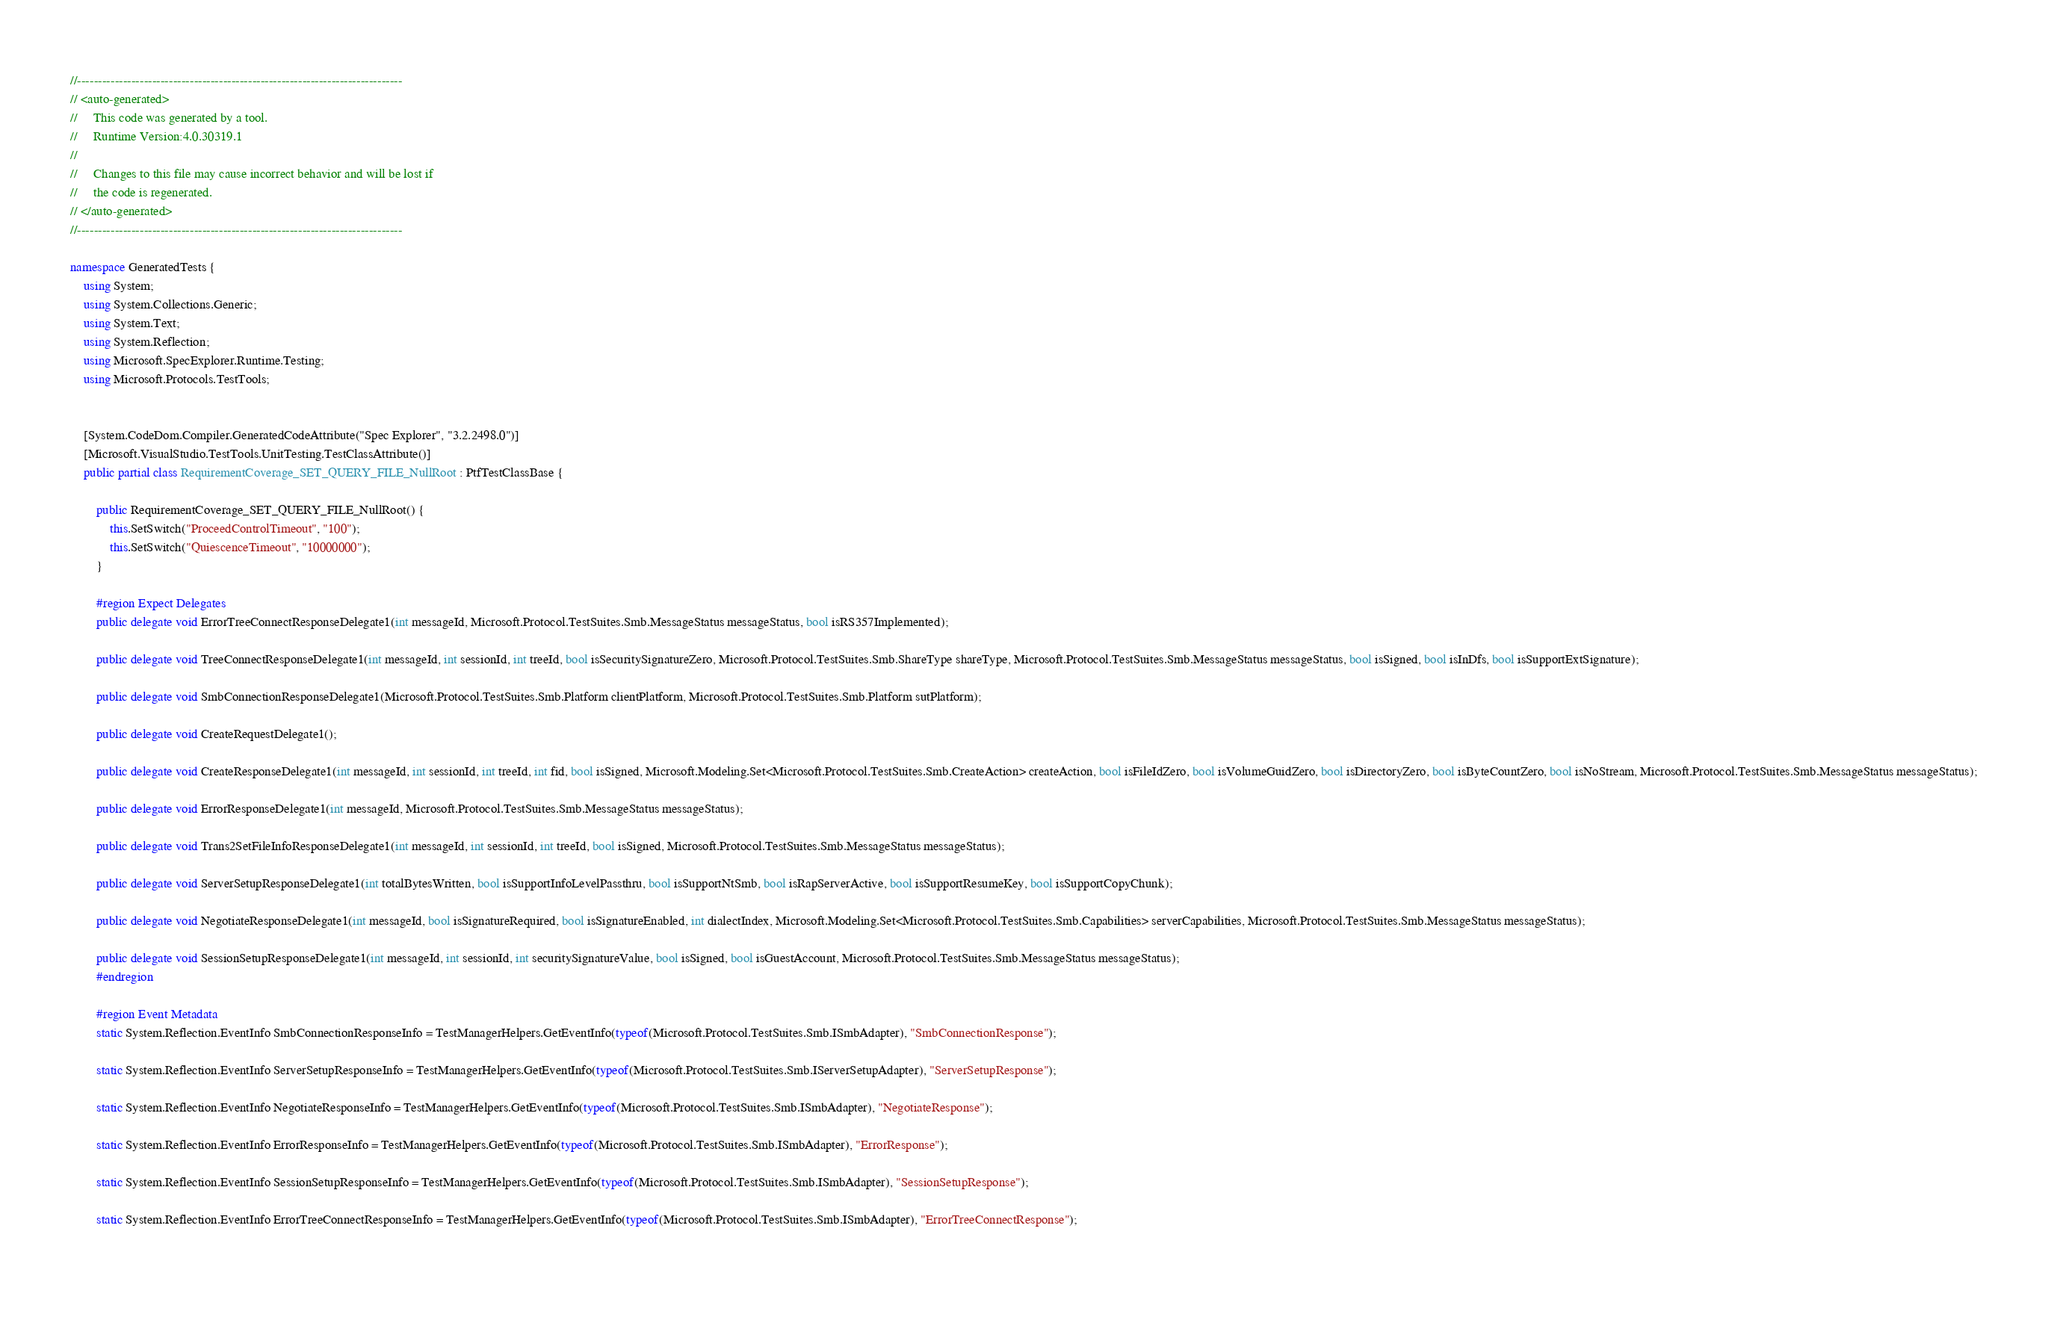Convert code to text. <code><loc_0><loc_0><loc_500><loc_500><_C#_>//------------------------------------------------------------------------------
// <auto-generated>
//     This code was generated by a tool.
//     Runtime Version:4.0.30319.1
//
//     Changes to this file may cause incorrect behavior and will be lost if
//     the code is regenerated.
// </auto-generated>
//------------------------------------------------------------------------------

namespace GeneratedTests {
    using System;
    using System.Collections.Generic;
    using System.Text;
    using System.Reflection;
    using Microsoft.SpecExplorer.Runtime.Testing;
    using Microsoft.Protocols.TestTools;
    
    
    [System.CodeDom.Compiler.GeneratedCodeAttribute("Spec Explorer", "3.2.2498.0")]
    [Microsoft.VisualStudio.TestTools.UnitTesting.TestClassAttribute()]
    public partial class RequirementCoverage_SET_QUERY_FILE_NullRoot : PtfTestClassBase {
        
        public RequirementCoverage_SET_QUERY_FILE_NullRoot() {
            this.SetSwitch("ProceedControlTimeout", "100");
            this.SetSwitch("QuiescenceTimeout", "10000000");
        }
        
        #region Expect Delegates
        public delegate void ErrorTreeConnectResponseDelegate1(int messageId, Microsoft.Protocol.TestSuites.Smb.MessageStatus messageStatus, bool isRS357Implemented);
        
        public delegate void TreeConnectResponseDelegate1(int messageId, int sessionId, int treeId, bool isSecuritySignatureZero, Microsoft.Protocol.TestSuites.Smb.ShareType shareType, Microsoft.Protocol.TestSuites.Smb.MessageStatus messageStatus, bool isSigned, bool isInDfs, bool isSupportExtSignature);
        
        public delegate void SmbConnectionResponseDelegate1(Microsoft.Protocol.TestSuites.Smb.Platform clientPlatform, Microsoft.Protocol.TestSuites.Smb.Platform sutPlatform);
        
        public delegate void CreateRequestDelegate1();
        
        public delegate void CreateResponseDelegate1(int messageId, int sessionId, int treeId, int fid, bool isSigned, Microsoft.Modeling.Set<Microsoft.Protocol.TestSuites.Smb.CreateAction> createAction, bool isFileIdZero, bool isVolumeGuidZero, bool isDirectoryZero, bool isByteCountZero, bool isNoStream, Microsoft.Protocol.TestSuites.Smb.MessageStatus messageStatus);
        
        public delegate void ErrorResponseDelegate1(int messageId, Microsoft.Protocol.TestSuites.Smb.MessageStatus messageStatus);
        
        public delegate void Trans2SetFileInfoResponseDelegate1(int messageId, int sessionId, int treeId, bool isSigned, Microsoft.Protocol.TestSuites.Smb.MessageStatus messageStatus);
        
        public delegate void ServerSetupResponseDelegate1(int totalBytesWritten, bool isSupportInfoLevelPassthru, bool isSupportNtSmb, bool isRapServerActive, bool isSupportResumeKey, bool isSupportCopyChunk);
        
        public delegate void NegotiateResponseDelegate1(int messageId, bool isSignatureRequired, bool isSignatureEnabled, int dialectIndex, Microsoft.Modeling.Set<Microsoft.Protocol.TestSuites.Smb.Capabilities> serverCapabilities, Microsoft.Protocol.TestSuites.Smb.MessageStatus messageStatus);
        
        public delegate void SessionSetupResponseDelegate1(int messageId, int sessionId, int securitySignatureValue, bool isSigned, bool isGuestAccount, Microsoft.Protocol.TestSuites.Smb.MessageStatus messageStatus);
        #endregion
        
        #region Event Metadata
        static System.Reflection.EventInfo SmbConnectionResponseInfo = TestManagerHelpers.GetEventInfo(typeof(Microsoft.Protocol.TestSuites.Smb.ISmbAdapter), "SmbConnectionResponse");
        
        static System.Reflection.EventInfo ServerSetupResponseInfo = TestManagerHelpers.GetEventInfo(typeof(Microsoft.Protocol.TestSuites.Smb.IServerSetupAdapter), "ServerSetupResponse");
        
        static System.Reflection.EventInfo NegotiateResponseInfo = TestManagerHelpers.GetEventInfo(typeof(Microsoft.Protocol.TestSuites.Smb.ISmbAdapter), "NegotiateResponse");
        
        static System.Reflection.EventInfo ErrorResponseInfo = TestManagerHelpers.GetEventInfo(typeof(Microsoft.Protocol.TestSuites.Smb.ISmbAdapter), "ErrorResponse");
        
        static System.Reflection.EventInfo SessionSetupResponseInfo = TestManagerHelpers.GetEventInfo(typeof(Microsoft.Protocol.TestSuites.Smb.ISmbAdapter), "SessionSetupResponse");
        
        static System.Reflection.EventInfo ErrorTreeConnectResponseInfo = TestManagerHelpers.GetEventInfo(typeof(Microsoft.Protocol.TestSuites.Smb.ISmbAdapter), "ErrorTreeConnectResponse");
        </code> 